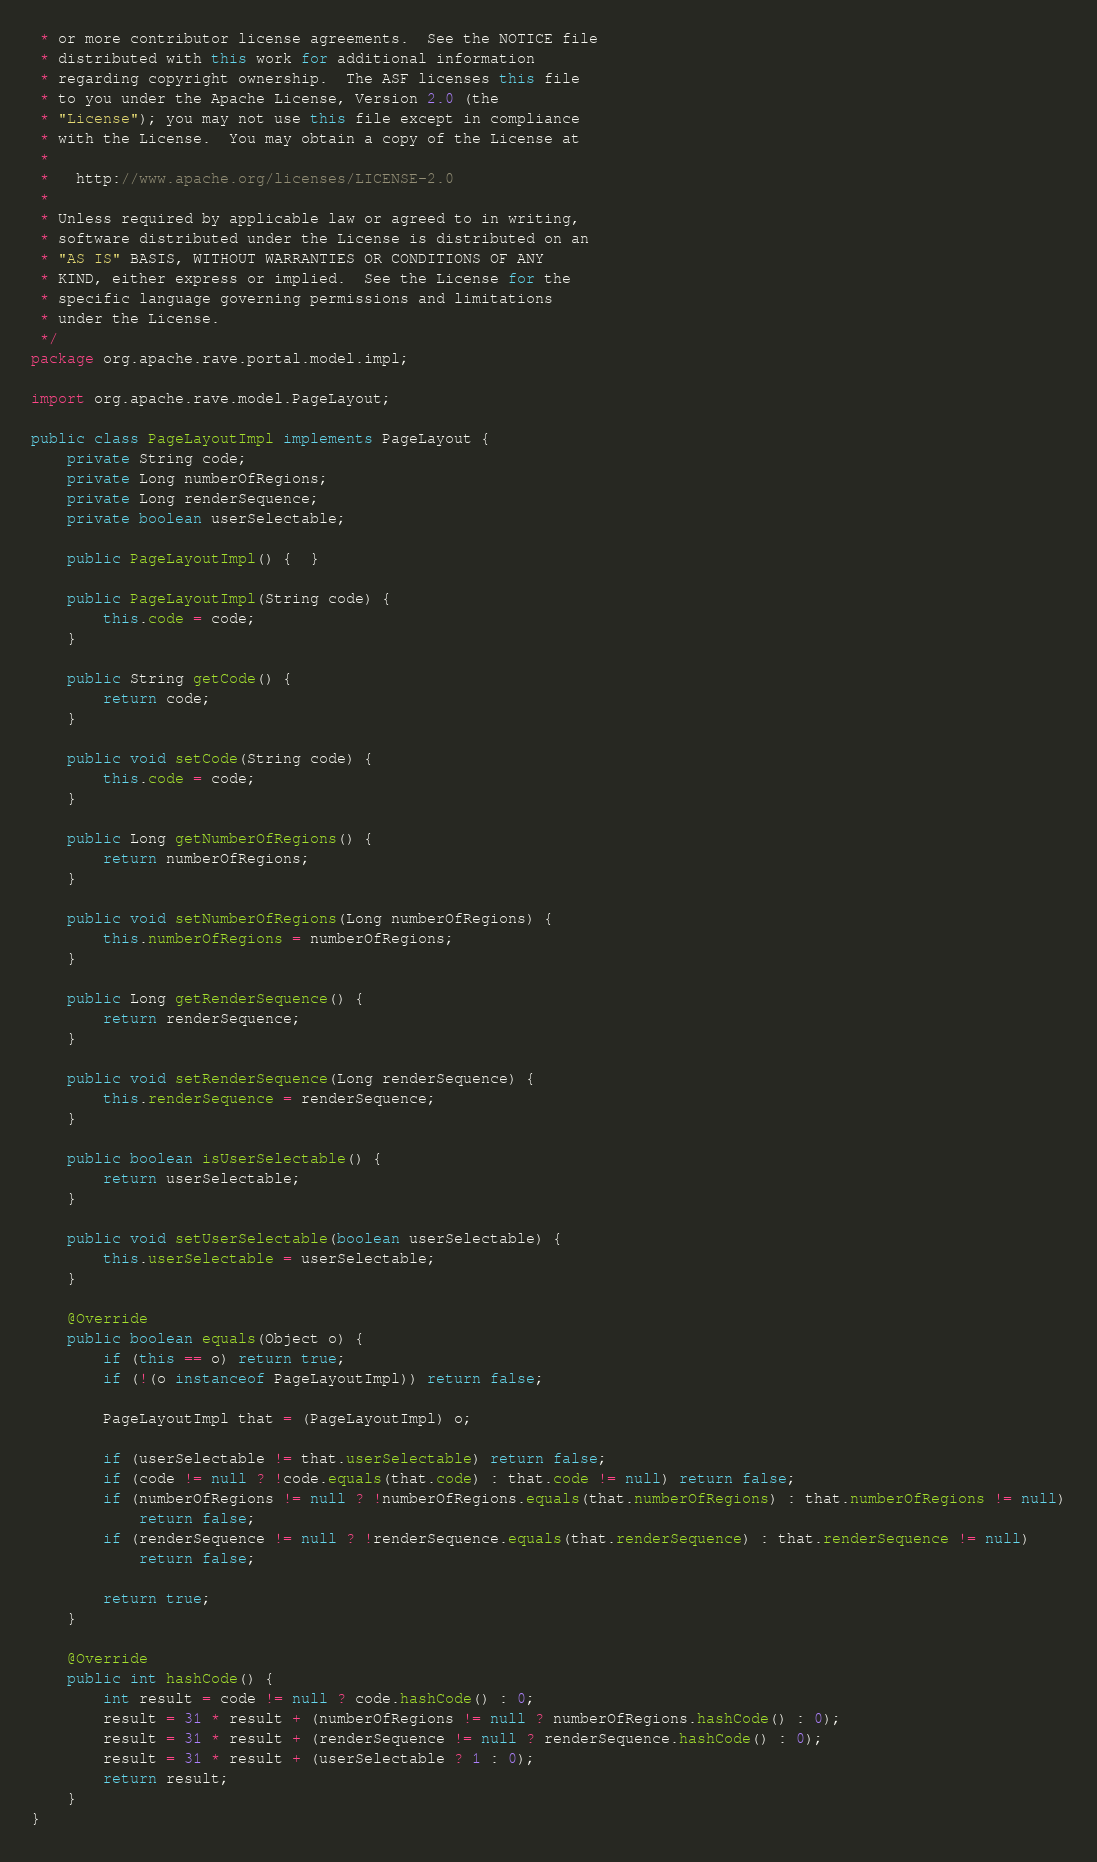<code> <loc_0><loc_0><loc_500><loc_500><_Java_> * or more contributor license agreements.  See the NOTICE file
 * distributed with this work for additional information
 * regarding copyright ownership.  The ASF licenses this file
 * to you under the Apache License, Version 2.0 (the
 * "License"); you may not use this file except in compliance
 * with the License.  You may obtain a copy of the License at
 *
 *   http://www.apache.org/licenses/LICENSE-2.0
 *
 * Unless required by applicable law or agreed to in writing,
 * software distributed under the License is distributed on an
 * "AS IS" BASIS, WITHOUT WARRANTIES OR CONDITIONS OF ANY
 * KIND, either express or implied.  See the License for the
 * specific language governing permissions and limitations
 * under the License.
 */
package org.apache.rave.portal.model.impl;

import org.apache.rave.model.PageLayout;

public class PageLayoutImpl implements PageLayout {
    private String code;
    private Long numberOfRegions;
    private Long renderSequence;
    private boolean userSelectable;

    public PageLayoutImpl() {  }

    public PageLayoutImpl(String code) {
        this.code = code;
    }

    public String getCode() {
        return code;
    }

    public void setCode(String code) {
        this.code = code;
    }

    public Long getNumberOfRegions() {
        return numberOfRegions;
    }

    public void setNumberOfRegions(Long numberOfRegions) {
        this.numberOfRegions = numberOfRegions;
    }

    public Long getRenderSequence() {
        return renderSequence;
    }

    public void setRenderSequence(Long renderSequence) {
        this.renderSequence = renderSequence;
    }

    public boolean isUserSelectable() {
        return userSelectable;
    }

    public void setUserSelectable(boolean userSelectable) {
        this.userSelectable = userSelectable;
    }

    @Override
    public boolean equals(Object o) {
        if (this == o) return true;
        if (!(o instanceof PageLayoutImpl)) return false;

        PageLayoutImpl that = (PageLayoutImpl) o;

        if (userSelectable != that.userSelectable) return false;
        if (code != null ? !code.equals(that.code) : that.code != null) return false;
        if (numberOfRegions != null ? !numberOfRegions.equals(that.numberOfRegions) : that.numberOfRegions != null)
            return false;
        if (renderSequence != null ? !renderSequence.equals(that.renderSequence) : that.renderSequence != null)
            return false;

        return true;
    }

    @Override
    public int hashCode() {
        int result = code != null ? code.hashCode() : 0;
        result = 31 * result + (numberOfRegions != null ? numberOfRegions.hashCode() : 0);
        result = 31 * result + (renderSequence != null ? renderSequence.hashCode() : 0);
        result = 31 * result + (userSelectable ? 1 : 0);
        return result;
    }
}
</code> 